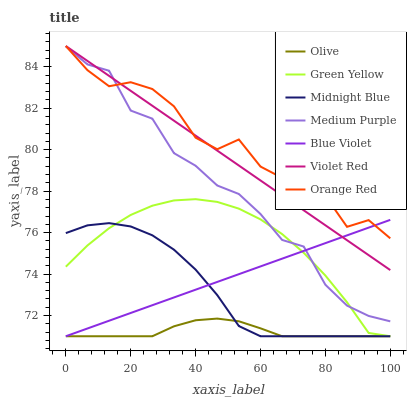Does Olive have the minimum area under the curve?
Answer yes or no. Yes. Does Orange Red have the maximum area under the curve?
Answer yes or no. Yes. Does Midnight Blue have the minimum area under the curve?
Answer yes or no. No. Does Midnight Blue have the maximum area under the curve?
Answer yes or no. No. Is Violet Red the smoothest?
Answer yes or no. Yes. Is Orange Red the roughest?
Answer yes or no. Yes. Is Midnight Blue the smoothest?
Answer yes or no. No. Is Midnight Blue the roughest?
Answer yes or no. No. Does Midnight Blue have the lowest value?
Answer yes or no. Yes. Does Medium Purple have the lowest value?
Answer yes or no. No. Does Orange Red have the highest value?
Answer yes or no. Yes. Does Midnight Blue have the highest value?
Answer yes or no. No. Is Green Yellow less than Orange Red?
Answer yes or no. Yes. Is Violet Red greater than Midnight Blue?
Answer yes or no. Yes. Does Blue Violet intersect Orange Red?
Answer yes or no. Yes. Is Blue Violet less than Orange Red?
Answer yes or no. No. Is Blue Violet greater than Orange Red?
Answer yes or no. No. Does Green Yellow intersect Orange Red?
Answer yes or no. No. 